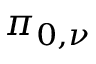<formula> <loc_0><loc_0><loc_500><loc_500>\pi _ { 0 , \nu }</formula> 